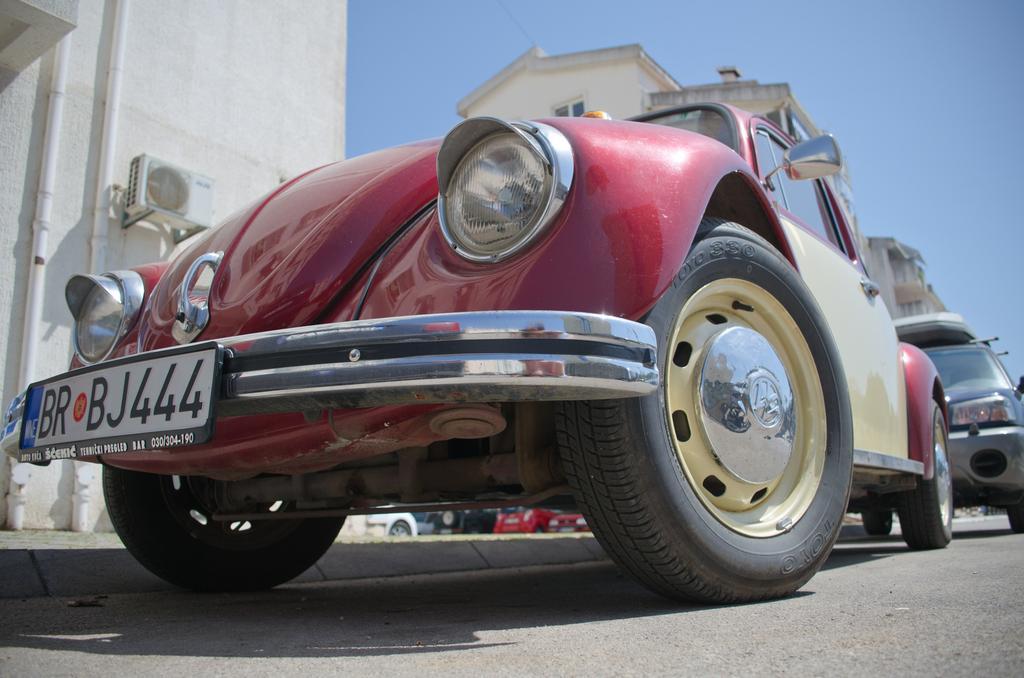Can you describe this image briefly? In this image we can see cars parked on the road. In the background, we can see buildings and the sky. 